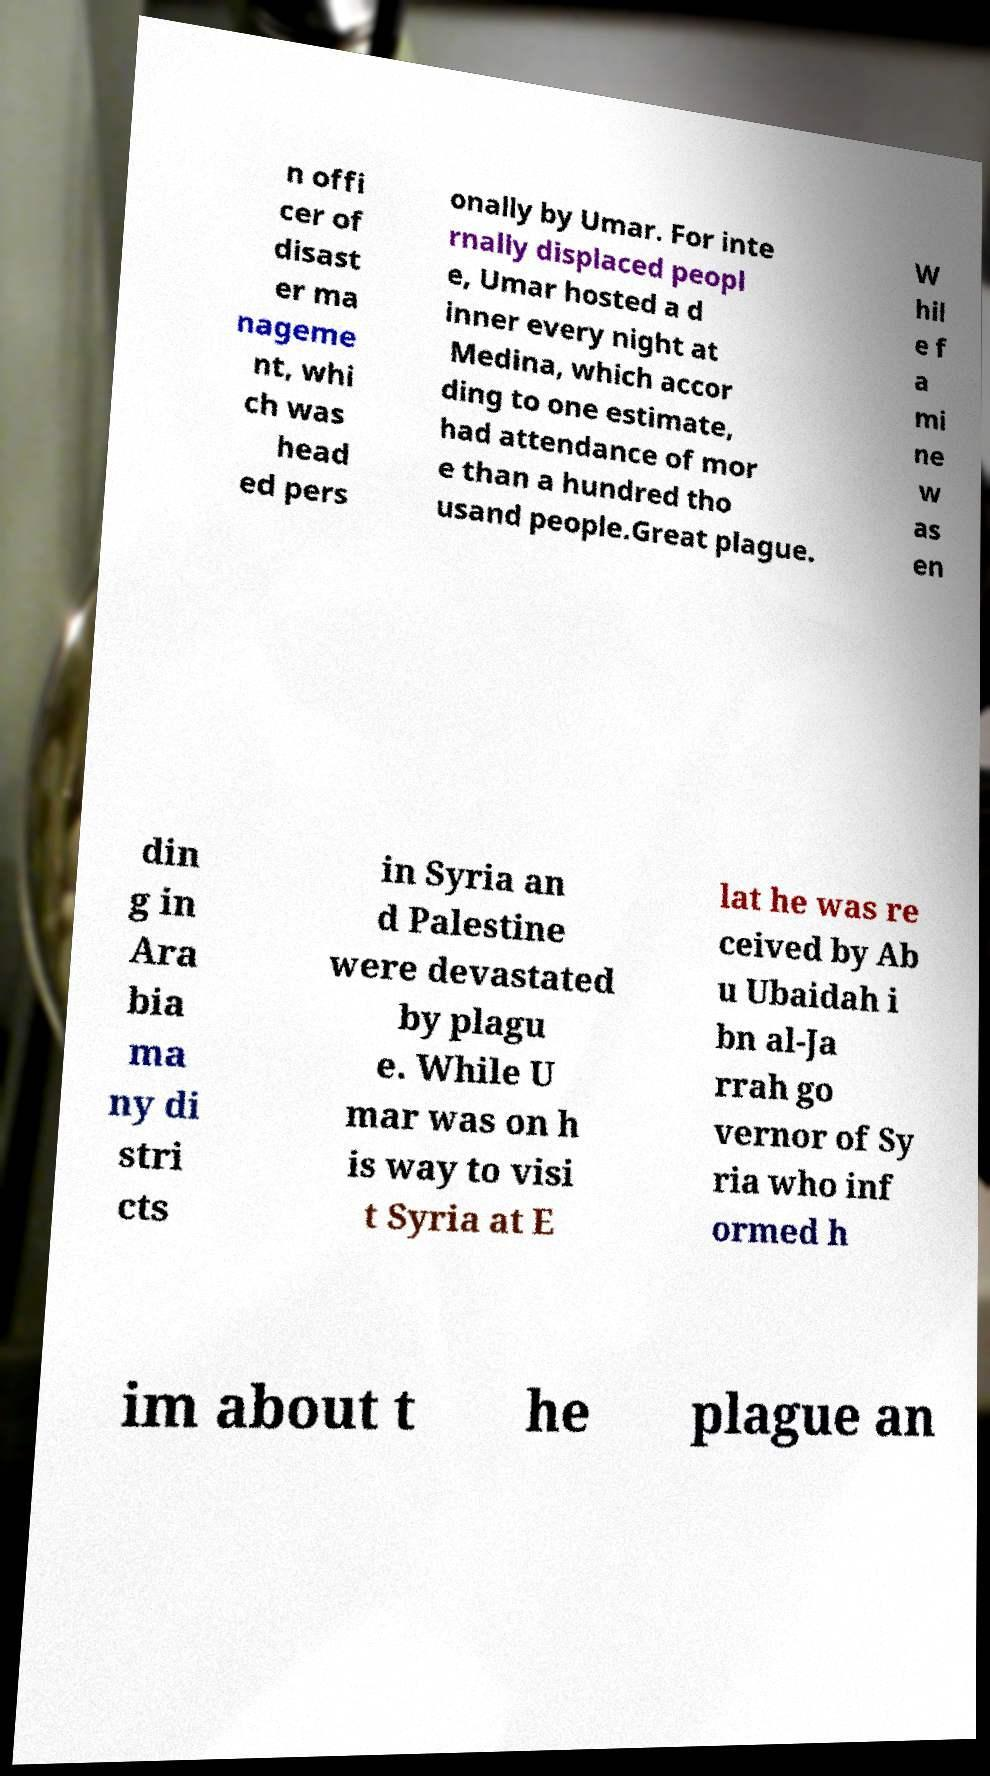There's text embedded in this image that I need extracted. Can you transcribe it verbatim? n offi cer of disast er ma nageme nt, whi ch was head ed pers onally by Umar. For inte rnally displaced peopl e, Umar hosted a d inner every night at Medina, which accor ding to one estimate, had attendance of mor e than a hundred tho usand people.Great plague. W hil e f a mi ne w as en din g in Ara bia ma ny di stri cts in Syria an d Palestine were devastated by plagu e. While U mar was on h is way to visi t Syria at E lat he was re ceived by Ab u Ubaidah i bn al-Ja rrah go vernor of Sy ria who inf ormed h im about t he plague an 